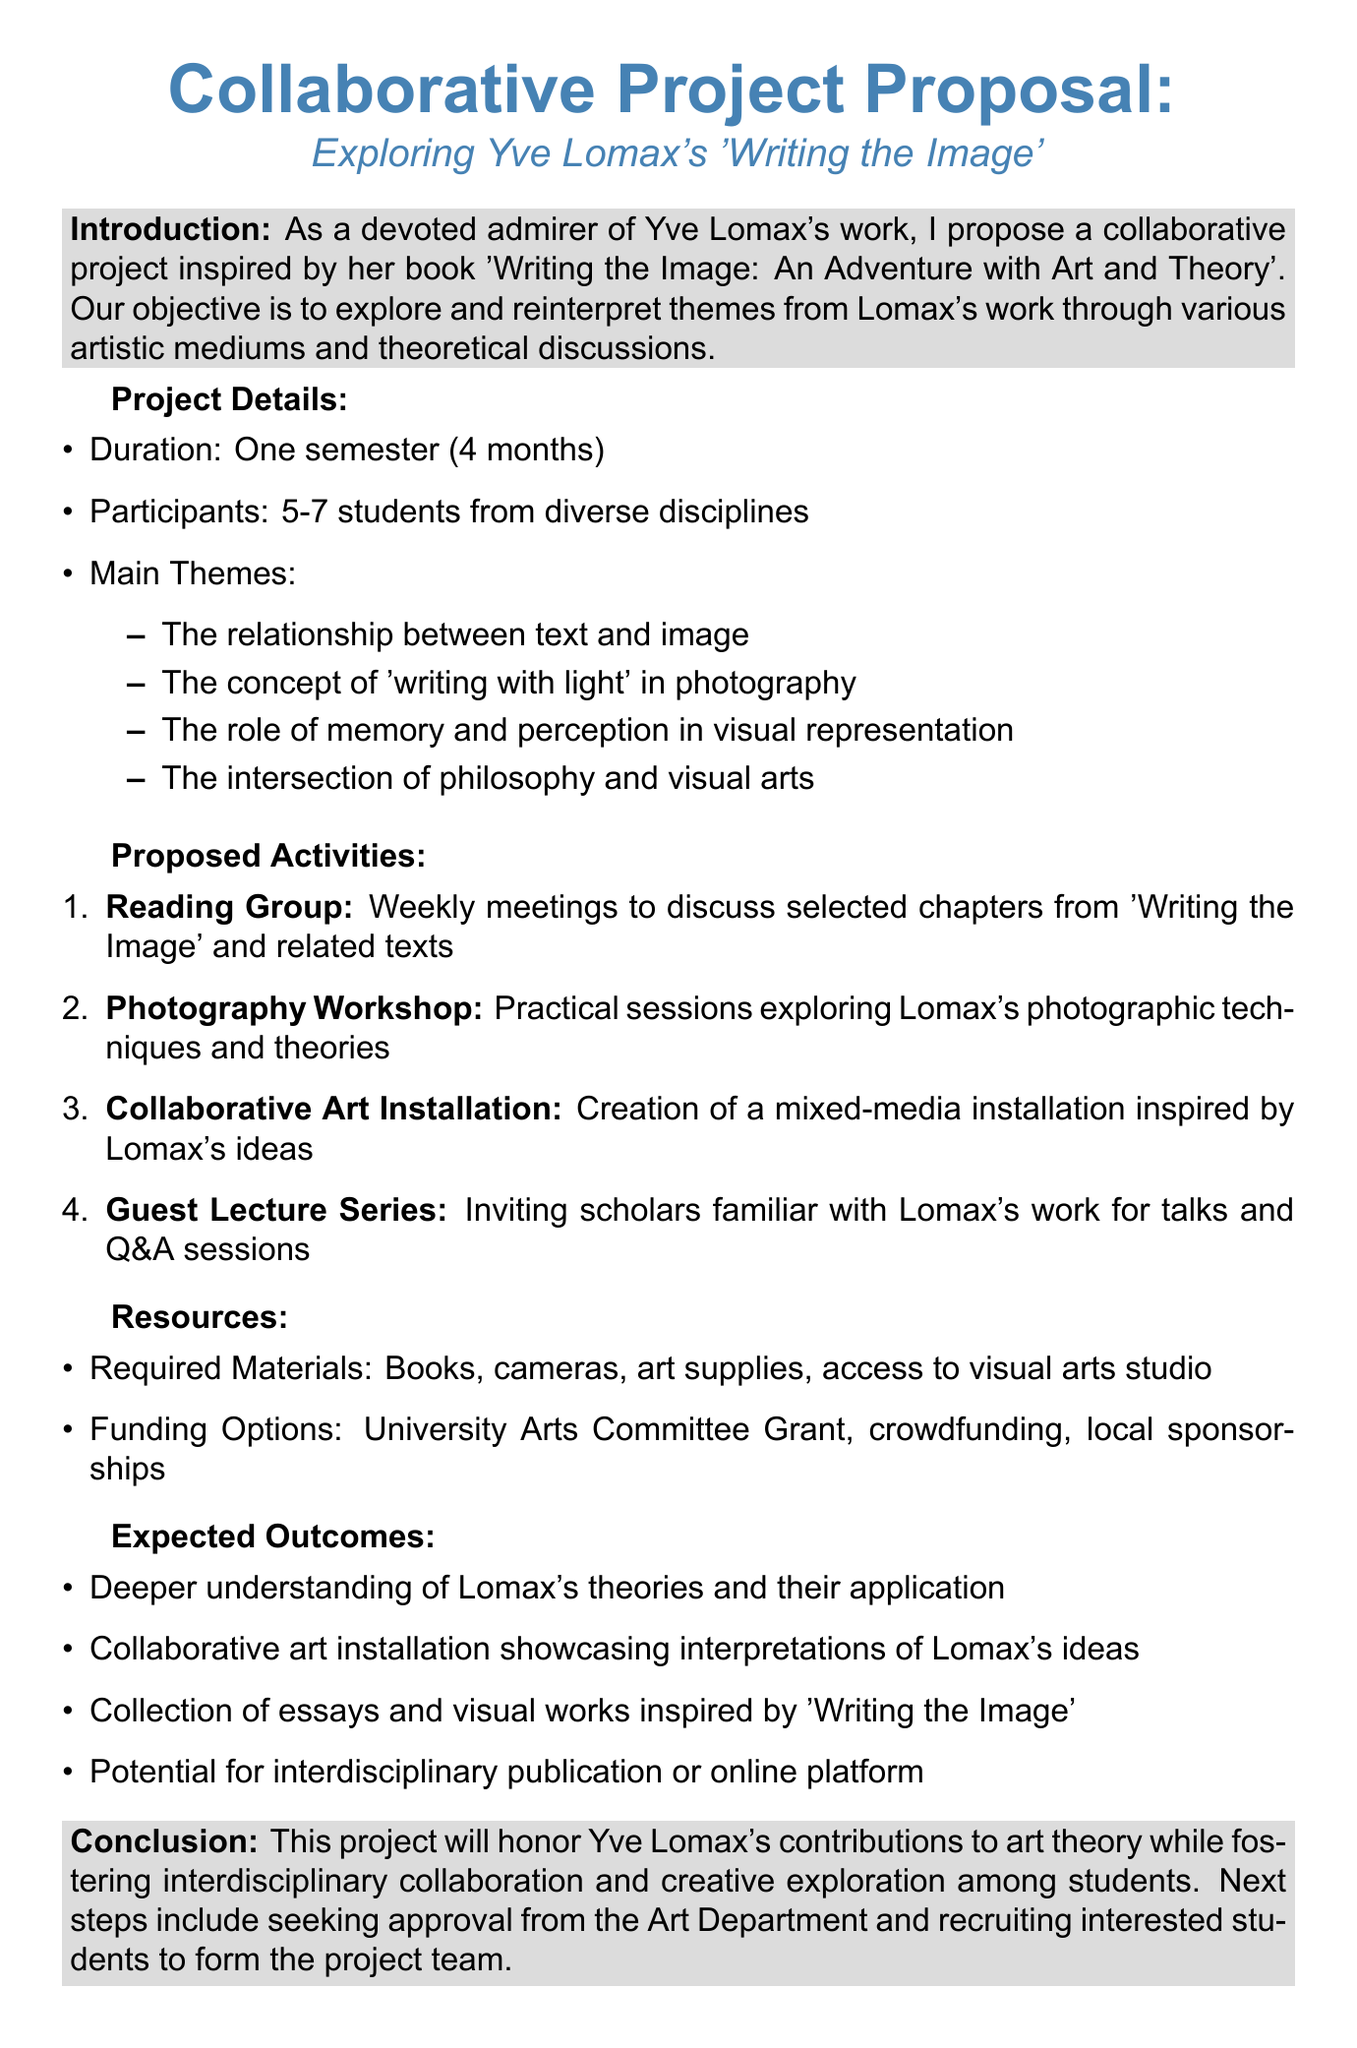What is the title of the proposed project? The title of the proposed project appears at the beginning of the memo, which is "Collaborative Project Proposal: Exploring Yve Lomax's 'Writing the Image'."
Answer: Collaborative Project Proposal: Exploring Yve Lomax's 'Writing the Image' How many students are planned to participate? The document states that 5-7 students are expected to participate in the project.
Answer: 5-7 students What is the duration of the project? The memo specifies that the duration of the project is one semester, which lasts 4 months.
Answer: One semester (4 months) Who will facilitate the photography workshop? The document mentions that Professor Sarah Chen from the Photography Department will facilitate the photography workshop.
Answer: Professor Sarah Chen What is one of the main themes explored in the project? The document lists several main themes, one of which is "The relationship between text and image."
Answer: The relationship between text and image What are the potential funding options mentioned? The memo lists three funding options: University Arts Committee Grant, crowdfunding, and local sponsorships.
Answer: University Arts Committee Grant, crowdfunding, local sponsorships What is the expected outcome related to Lomax’s theories? The document indicates that one expected outcome is a deeper understanding of Yve Lomax's theories and their application in contemporary art practices.
Answer: A deeper understanding of Yve Lomax's theories and their application What is the next step mentioned in the conclusion? The conclusion section of the memo states that the next steps include seeking approval from the Art Department and recruiting interested students to form the project team.
Answer: Seeking approval from the Art Department and recruiting interested students to form the project team 